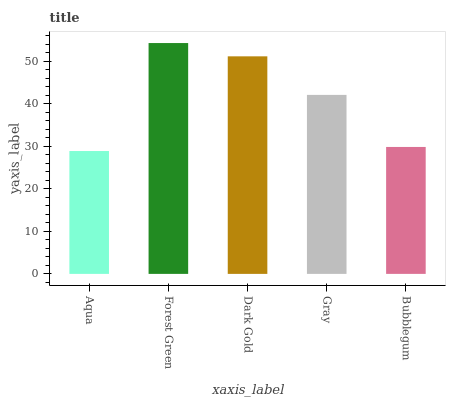Is Dark Gold the minimum?
Answer yes or no. No. Is Dark Gold the maximum?
Answer yes or no. No. Is Forest Green greater than Dark Gold?
Answer yes or no. Yes. Is Dark Gold less than Forest Green?
Answer yes or no. Yes. Is Dark Gold greater than Forest Green?
Answer yes or no. No. Is Forest Green less than Dark Gold?
Answer yes or no. No. Is Gray the high median?
Answer yes or no. Yes. Is Gray the low median?
Answer yes or no. Yes. Is Bubblegum the high median?
Answer yes or no. No. Is Forest Green the low median?
Answer yes or no. No. 